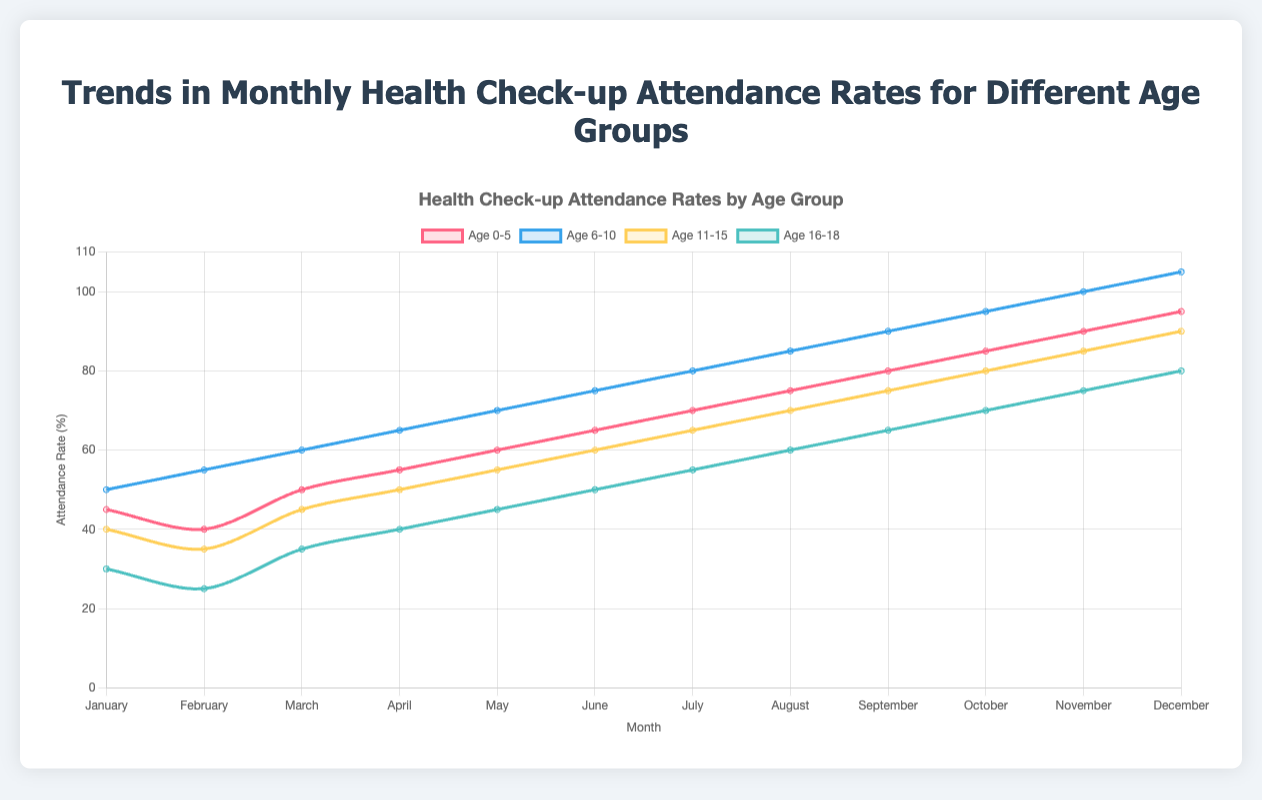Which month has the highest attendance rate for the age group 0-5? By looking at the figure, the highest peak for the red line (age group 0-5) occurs in December.
Answer: December How do the attendance rates for age group 6-10 in February compare to the rates in March? The blue line indicates the attendance rates for the age group 6-10. In February, the rate is 55, while in March, the rate is 60. Thus, the rate in March is higher than in February.
Answer: Higher in March What is the total attendance rate for the age group 11-15 from January to March? Sum the attendance rates for age group 11-15 from January (40), February (35), and March (45). Total = 40 + 35 + 45 = 120.
Answer: 120 Which age group showed the most significant increase in attendance rate from January to December? By comparing the starting and ending points of all lines, the green line (age group 6-10) increased from 50 in January to 105 in December, which is an increase of 55. This is the highest increase among all groups.
Answer: 6-10 What is the difference between the attendance rates of the age group 16-18 in June and November? The attendance rate for age group 16-18 in June is 50, and in November it is 75. The difference is 75 - 50 = 25.
Answer: 25 Which month shows the highest overall attendance rate across all age groups? By adding the attendance rates of all age groups for each month, December has the highest total. (95+105+90+80 = 370)
Answer: December How does the slope of the graph change for the age group 0-5 from August to September compared to September to October? The red line (age group 0-5) from August (75) to September (80) shows a smaller increase compared to the jump from September (80) to October (85).
Answer: Steeper from September to October Between March and April, which age group saw the smallest increase in attendance rates? The differences are: 0-5 (5), 6-10 (5), 11-15 (5), 16-18 (5). All age groups saw the same increase.
Answer: All same What is the average attendance rate for the age group 16-18 during the first quarter of the year (January to March)? Calculate the average by summing the rates and dividing by the number of months: (30 + 25 + 35) / 3 = 30.
Answer: 30 